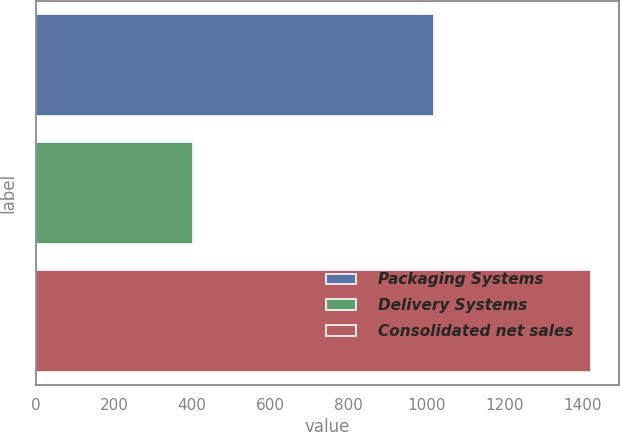<chart> <loc_0><loc_0><loc_500><loc_500><bar_chart><fcel>Packaging Systems<fcel>Delivery Systems<fcel>Consolidated net sales<nl><fcel>1019.7<fcel>402.5<fcel>1421.4<nl></chart> 